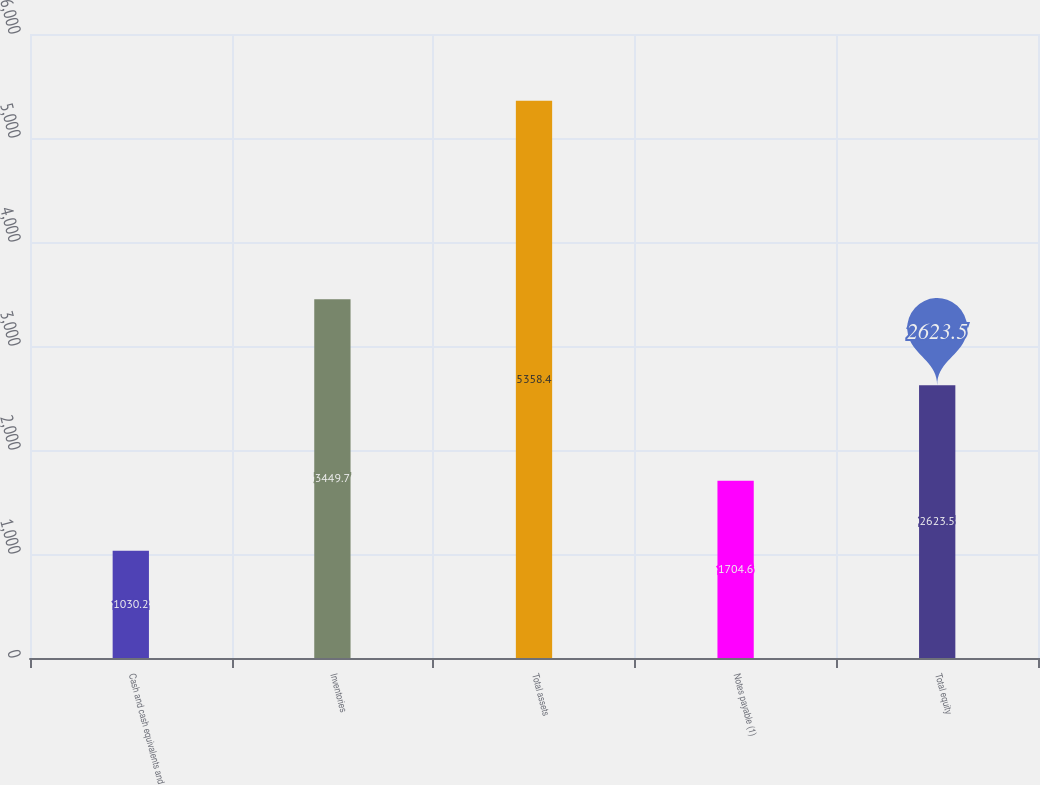Convert chart. <chart><loc_0><loc_0><loc_500><loc_500><bar_chart><fcel>Cash and cash equivalents and<fcel>Inventories<fcel>Total assets<fcel>Notes payable (1)<fcel>Total equity<nl><fcel>1030.2<fcel>3449.7<fcel>5358.4<fcel>1704.6<fcel>2623.5<nl></chart> 